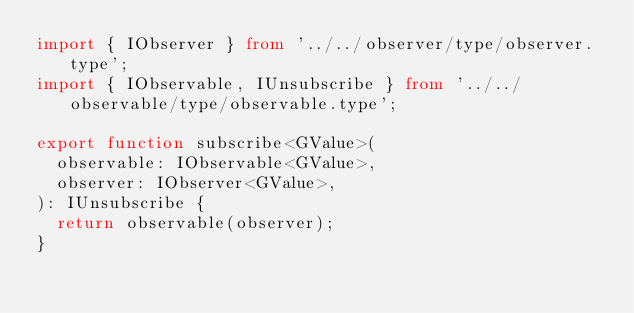Convert code to text. <code><loc_0><loc_0><loc_500><loc_500><_TypeScript_>import { IObserver } from '../../observer/type/observer.type';
import { IObservable, IUnsubscribe } from '../../observable/type/observable.type';

export function subscribe<GValue>(
  observable: IObservable<GValue>,
  observer: IObserver<GValue>,
): IUnsubscribe {
  return observable(observer);
}
</code> 